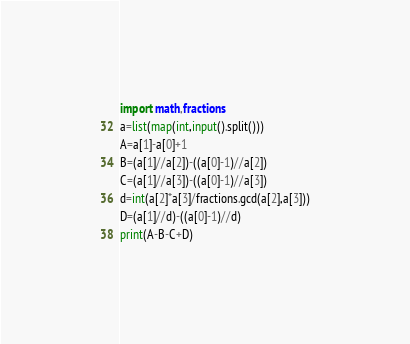Convert code to text. <code><loc_0><loc_0><loc_500><loc_500><_Python_>import math,fractions
a=list(map(int,input().split()))
A=a[1]-a[0]+1
B=(a[1]//a[2])-((a[0]-1)//a[2])
C=(a[1]//a[3])-((a[0]-1)//a[3])
d=int(a[2]*a[3]/fractions.gcd(a[2],a[3]))
D=(a[1]//d)-((a[0]-1)//d)
print(A-B-C+D)</code> 